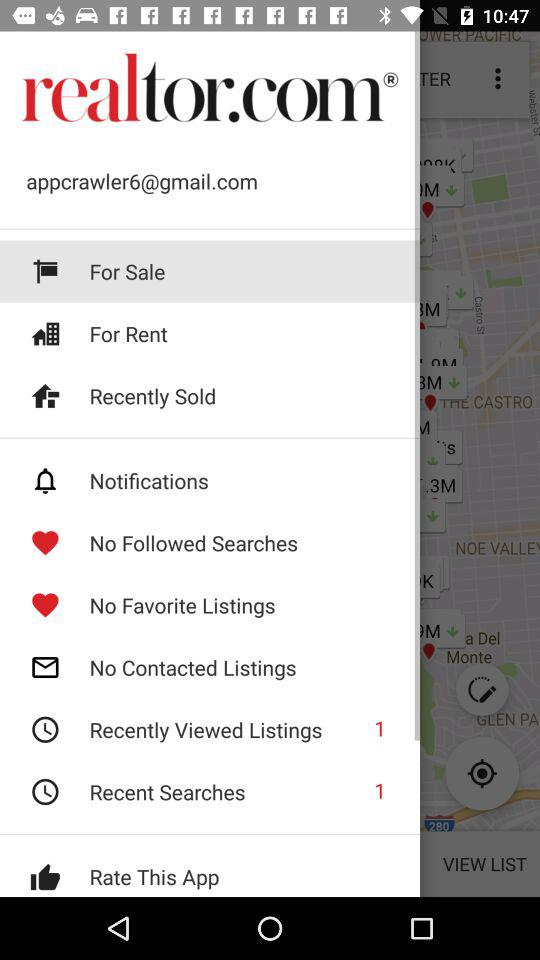What is the number of items in "Recently Viewed Listings"? The number of items in "Recently Viewed Listings" is 1. 